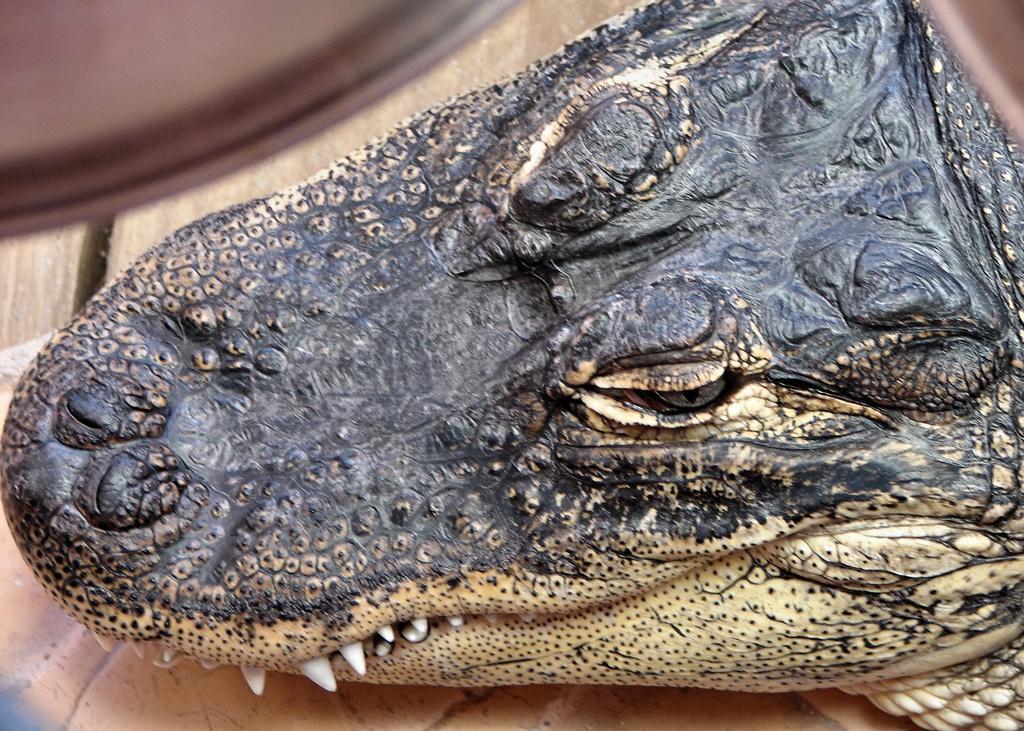Please provide a concise description of this image. In the image we can see a american alligator. 